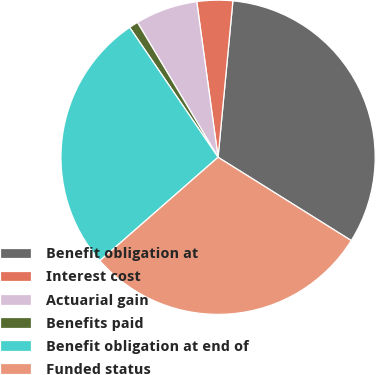Convert chart. <chart><loc_0><loc_0><loc_500><loc_500><pie_chart><fcel>Benefit obligation at<fcel>Interest cost<fcel>Actuarial gain<fcel>Benefits paid<fcel>Benefit obligation at end of<fcel>Funded status<nl><fcel>32.39%<fcel>3.67%<fcel>6.41%<fcel>0.94%<fcel>26.93%<fcel>29.66%<nl></chart> 